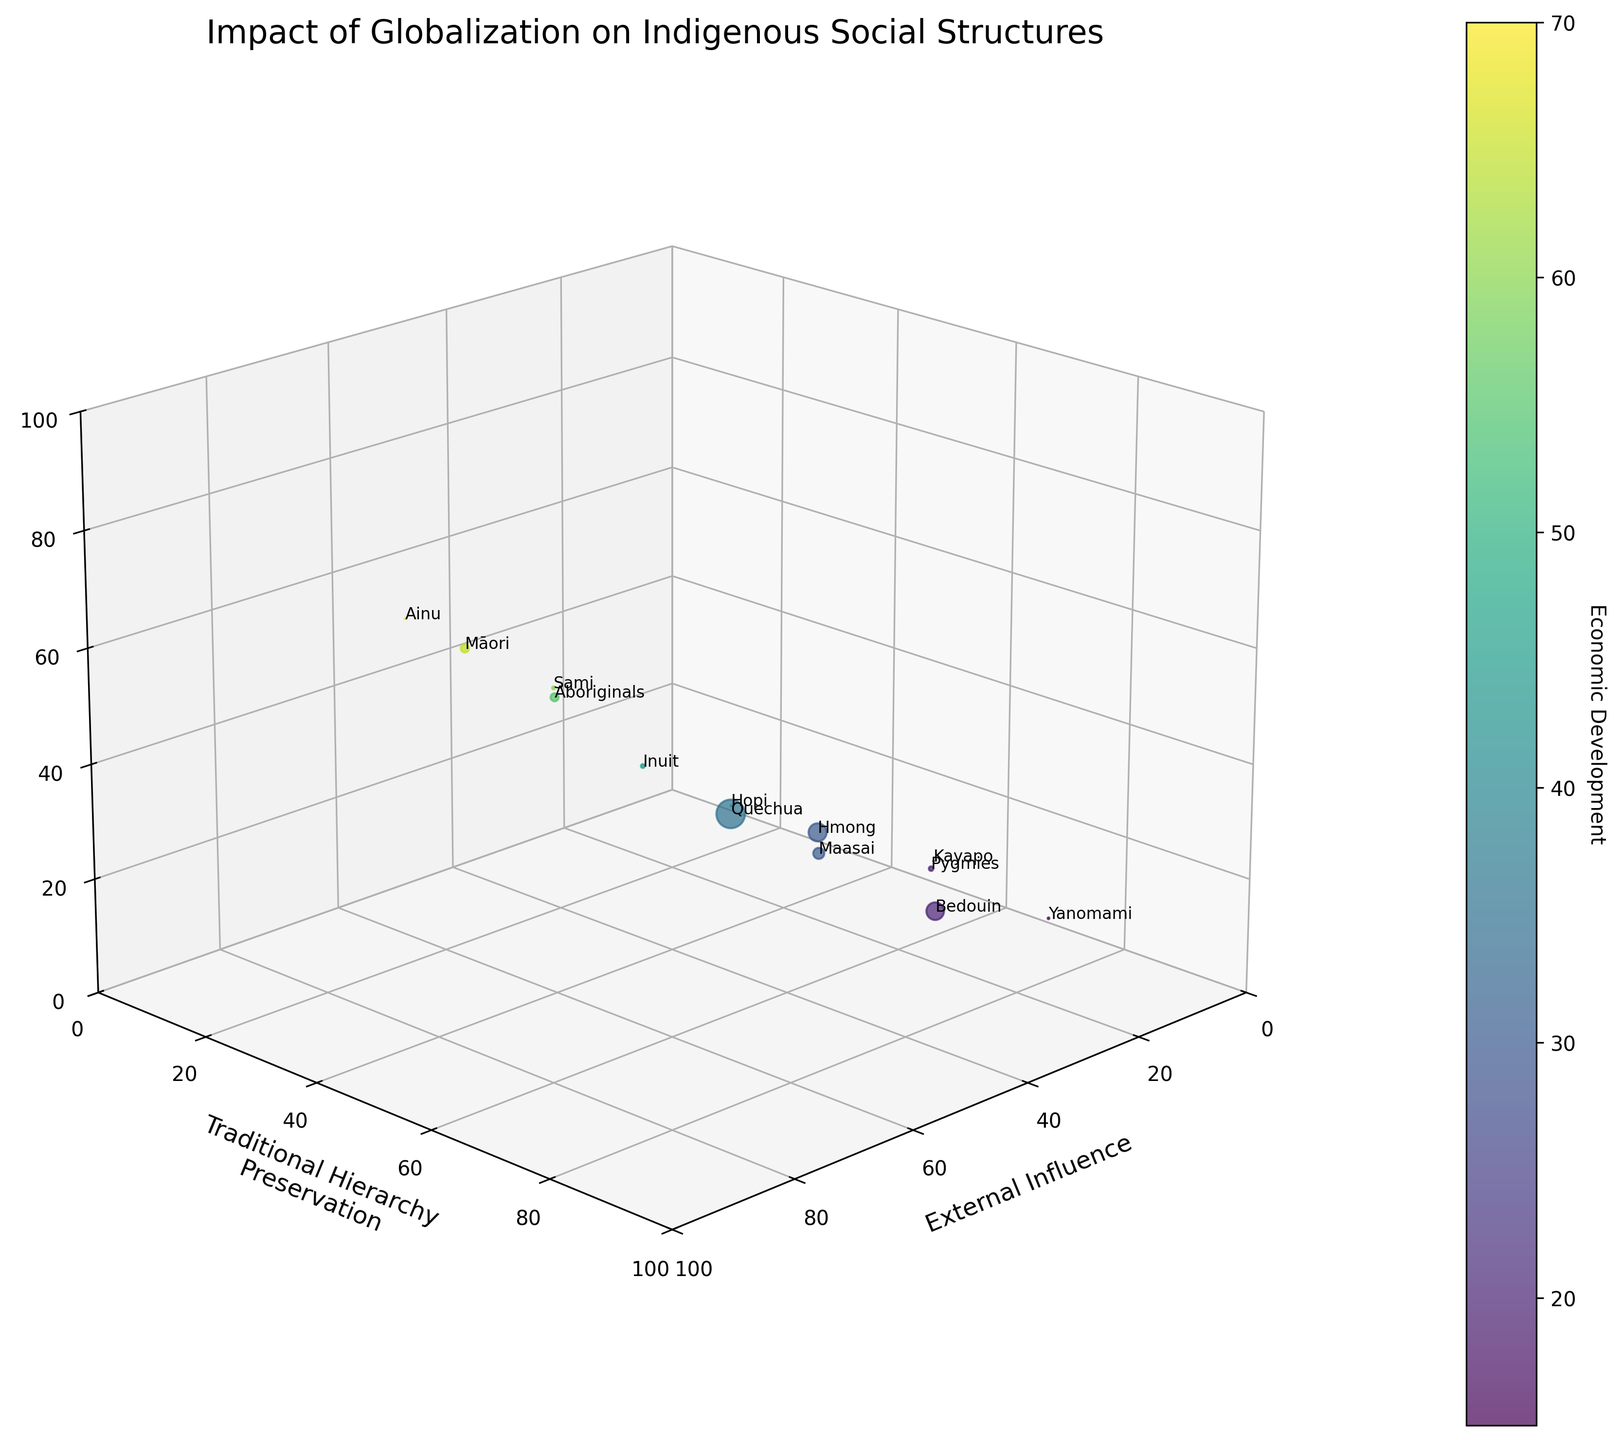What is the title of the figure? The title is displayed prominently at the top of the figure.
Answer: Impact of Globalization on Indigenous Social Structures Which axis represents the degree of external influence? The x-axis is labeled as 'External Influence'.
Answer: x-axis Which community shows the highest economic development? By looking at the z-axis values, the Māori have the highest economic development with a z-value of 65.
Answer: Māori Which community has the smallest population and where is it located in the plot? The Yanomami community has a population of 38,000. They are located at (20, 85, 15) on the [External Influence, Traditional Hierarchy Preservation, Economic Development] axes.
Answer: Yanomami at (20, 85, 15) What is the range of traditional hierarchy preservation values covered by the communities? The lowest value for traditional hierarchy preservation is 35 (Ainu), and the highest is 85 (Yanomami). So the range is from 35 to 85.
Answer: 35 to 85 Which community is situated at the highest point on the 'External Influence' axis and what is its traditional hierarchy preservation value? By observing the x-axis, Ainu has the highest value on the 'External Influence' axis with a value of 80, and their traditional hierarchy preservation value is 35.
Answer: Ainu, 35 Compare the traditional hierarchy preservation and economic development indexes for the Hmong and Hopi communities. Hmong has a traditional hierarchy preservation of 65 and economic development of 30. Hopi has traditional hierarchy preservation of 65 and economic development of 40. Therefore, Hopi has higher economic development while both have the same traditional hierarchy preservation.
Answer: Hmong: 65/30, Hopi: 65/40 Which community has the closest balance between external influence and traditional hierarchy preservation, and what is their economic development? Looking for communities where external influence and traditional hierarchy preservation are numerically closest, we find that the Hopi, with 55 external influence and 65 traditional hierarchy preservation, are closely balanced. Their economic development is 40.
Answer: Hopi, 40 Between the Bedouin and the Pygmies, which community has higher economic development, and by how much? Bedouin have an economic development of 20, whereas Pygmies have 20 as well. Hence, there is no difference in economic development values.
Answer: None, 0 What's the average external influence among the communities with over 1 million population? The Māori (75), Quechua (50), Hmong (40), Bedouin (35), and Maasai (45) each have populations over 1 million. The average is (75 + 50 + 40 + 35 + 45) / 5 = 49.
Answer: 49 